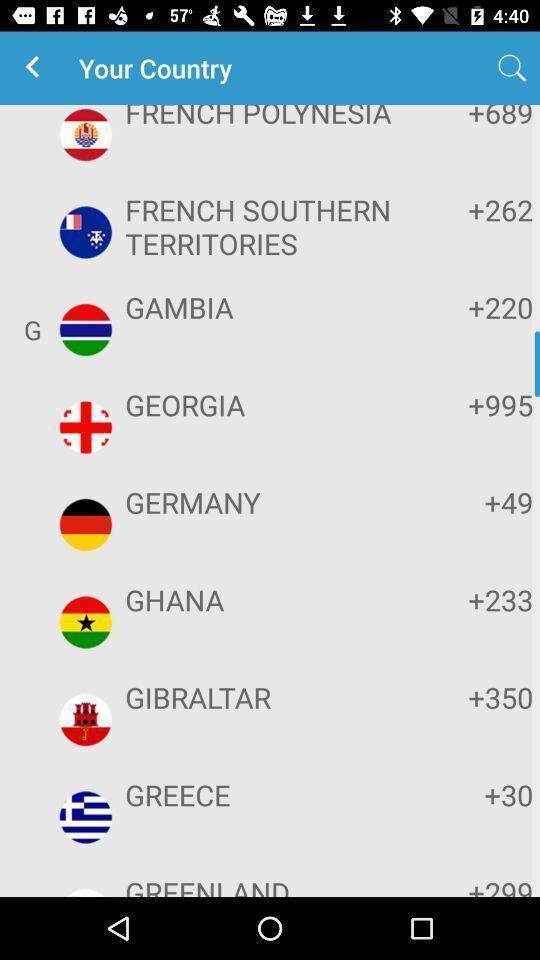Summarize the main components in this picture. Screen showing list of countries with code. 